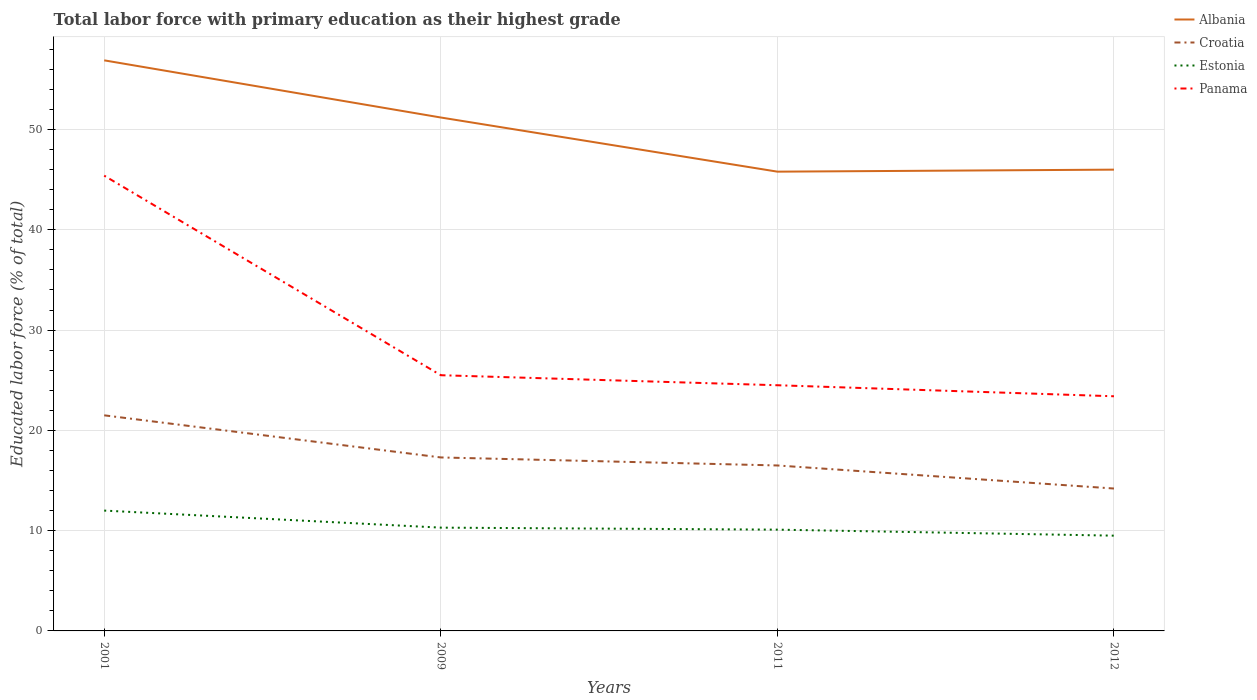How many different coloured lines are there?
Offer a very short reply. 4. Does the line corresponding to Estonia intersect with the line corresponding to Panama?
Offer a very short reply. No. Across all years, what is the maximum percentage of total labor force with primary education in Albania?
Ensure brevity in your answer.  45.8. What is the total percentage of total labor force with primary education in Croatia in the graph?
Offer a terse response. 7.3. What is the difference between the highest and the second highest percentage of total labor force with primary education in Croatia?
Keep it short and to the point. 7.3. What is the difference between the highest and the lowest percentage of total labor force with primary education in Estonia?
Your answer should be very brief. 1. Is the percentage of total labor force with primary education in Croatia strictly greater than the percentage of total labor force with primary education in Albania over the years?
Make the answer very short. Yes. How many years are there in the graph?
Your answer should be compact. 4. What is the difference between two consecutive major ticks on the Y-axis?
Provide a short and direct response. 10. Are the values on the major ticks of Y-axis written in scientific E-notation?
Offer a terse response. No. Does the graph contain grids?
Provide a short and direct response. Yes. Where does the legend appear in the graph?
Your answer should be compact. Top right. What is the title of the graph?
Your answer should be very brief. Total labor force with primary education as their highest grade. What is the label or title of the Y-axis?
Offer a very short reply. Educated labor force (% of total). What is the Educated labor force (% of total) in Albania in 2001?
Offer a terse response. 56.9. What is the Educated labor force (% of total) of Croatia in 2001?
Provide a succinct answer. 21.5. What is the Educated labor force (% of total) of Panama in 2001?
Give a very brief answer. 45.4. What is the Educated labor force (% of total) in Albania in 2009?
Your answer should be very brief. 51.2. What is the Educated labor force (% of total) of Croatia in 2009?
Provide a short and direct response. 17.3. What is the Educated labor force (% of total) of Estonia in 2009?
Provide a short and direct response. 10.3. What is the Educated labor force (% of total) of Albania in 2011?
Your response must be concise. 45.8. What is the Educated labor force (% of total) in Estonia in 2011?
Your response must be concise. 10.1. What is the Educated labor force (% of total) in Albania in 2012?
Offer a very short reply. 46. What is the Educated labor force (% of total) of Croatia in 2012?
Your response must be concise. 14.2. What is the Educated labor force (% of total) of Estonia in 2012?
Keep it short and to the point. 9.5. What is the Educated labor force (% of total) in Panama in 2012?
Keep it short and to the point. 23.4. Across all years, what is the maximum Educated labor force (% of total) in Albania?
Make the answer very short. 56.9. Across all years, what is the maximum Educated labor force (% of total) in Croatia?
Keep it short and to the point. 21.5. Across all years, what is the maximum Educated labor force (% of total) in Estonia?
Give a very brief answer. 12. Across all years, what is the maximum Educated labor force (% of total) in Panama?
Offer a very short reply. 45.4. Across all years, what is the minimum Educated labor force (% of total) of Albania?
Provide a succinct answer. 45.8. Across all years, what is the minimum Educated labor force (% of total) of Croatia?
Offer a very short reply. 14.2. Across all years, what is the minimum Educated labor force (% of total) in Panama?
Offer a terse response. 23.4. What is the total Educated labor force (% of total) in Albania in the graph?
Make the answer very short. 199.9. What is the total Educated labor force (% of total) of Croatia in the graph?
Keep it short and to the point. 69.5. What is the total Educated labor force (% of total) in Estonia in the graph?
Give a very brief answer. 41.9. What is the total Educated labor force (% of total) of Panama in the graph?
Provide a succinct answer. 118.8. What is the difference between the Educated labor force (% of total) of Albania in 2001 and that in 2011?
Ensure brevity in your answer.  11.1. What is the difference between the Educated labor force (% of total) of Croatia in 2001 and that in 2011?
Make the answer very short. 5. What is the difference between the Educated labor force (% of total) of Estonia in 2001 and that in 2011?
Offer a very short reply. 1.9. What is the difference between the Educated labor force (% of total) in Panama in 2001 and that in 2011?
Provide a succinct answer. 20.9. What is the difference between the Educated labor force (% of total) in Albania in 2001 and that in 2012?
Your response must be concise. 10.9. What is the difference between the Educated labor force (% of total) of Albania in 2009 and that in 2011?
Give a very brief answer. 5.4. What is the difference between the Educated labor force (% of total) in Croatia in 2009 and that in 2012?
Provide a short and direct response. 3.1. What is the difference between the Educated labor force (% of total) in Estonia in 2009 and that in 2012?
Your answer should be compact. 0.8. What is the difference between the Educated labor force (% of total) of Panama in 2009 and that in 2012?
Your answer should be very brief. 2.1. What is the difference between the Educated labor force (% of total) of Albania in 2011 and that in 2012?
Your answer should be compact. -0.2. What is the difference between the Educated labor force (% of total) of Croatia in 2011 and that in 2012?
Your response must be concise. 2.3. What is the difference between the Educated labor force (% of total) of Panama in 2011 and that in 2012?
Your answer should be compact. 1.1. What is the difference between the Educated labor force (% of total) of Albania in 2001 and the Educated labor force (% of total) of Croatia in 2009?
Offer a very short reply. 39.6. What is the difference between the Educated labor force (% of total) in Albania in 2001 and the Educated labor force (% of total) in Estonia in 2009?
Offer a very short reply. 46.6. What is the difference between the Educated labor force (% of total) of Albania in 2001 and the Educated labor force (% of total) of Panama in 2009?
Keep it short and to the point. 31.4. What is the difference between the Educated labor force (% of total) in Croatia in 2001 and the Educated labor force (% of total) in Panama in 2009?
Your answer should be very brief. -4. What is the difference between the Educated labor force (% of total) in Estonia in 2001 and the Educated labor force (% of total) in Panama in 2009?
Ensure brevity in your answer.  -13.5. What is the difference between the Educated labor force (% of total) in Albania in 2001 and the Educated labor force (% of total) in Croatia in 2011?
Offer a very short reply. 40.4. What is the difference between the Educated labor force (% of total) in Albania in 2001 and the Educated labor force (% of total) in Estonia in 2011?
Your answer should be very brief. 46.8. What is the difference between the Educated labor force (% of total) of Albania in 2001 and the Educated labor force (% of total) of Panama in 2011?
Your answer should be very brief. 32.4. What is the difference between the Educated labor force (% of total) in Croatia in 2001 and the Educated labor force (% of total) in Panama in 2011?
Provide a short and direct response. -3. What is the difference between the Educated labor force (% of total) in Albania in 2001 and the Educated labor force (% of total) in Croatia in 2012?
Provide a short and direct response. 42.7. What is the difference between the Educated labor force (% of total) of Albania in 2001 and the Educated labor force (% of total) of Estonia in 2012?
Your answer should be compact. 47.4. What is the difference between the Educated labor force (% of total) of Albania in 2001 and the Educated labor force (% of total) of Panama in 2012?
Ensure brevity in your answer.  33.5. What is the difference between the Educated labor force (% of total) in Croatia in 2001 and the Educated labor force (% of total) in Estonia in 2012?
Offer a terse response. 12. What is the difference between the Educated labor force (% of total) in Croatia in 2001 and the Educated labor force (% of total) in Panama in 2012?
Your response must be concise. -1.9. What is the difference between the Educated labor force (% of total) in Estonia in 2001 and the Educated labor force (% of total) in Panama in 2012?
Ensure brevity in your answer.  -11.4. What is the difference between the Educated labor force (% of total) of Albania in 2009 and the Educated labor force (% of total) of Croatia in 2011?
Offer a very short reply. 34.7. What is the difference between the Educated labor force (% of total) of Albania in 2009 and the Educated labor force (% of total) of Estonia in 2011?
Your response must be concise. 41.1. What is the difference between the Educated labor force (% of total) of Albania in 2009 and the Educated labor force (% of total) of Panama in 2011?
Provide a short and direct response. 26.7. What is the difference between the Educated labor force (% of total) of Croatia in 2009 and the Educated labor force (% of total) of Panama in 2011?
Keep it short and to the point. -7.2. What is the difference between the Educated labor force (% of total) of Estonia in 2009 and the Educated labor force (% of total) of Panama in 2011?
Your answer should be compact. -14.2. What is the difference between the Educated labor force (% of total) in Albania in 2009 and the Educated labor force (% of total) in Croatia in 2012?
Provide a short and direct response. 37. What is the difference between the Educated labor force (% of total) in Albania in 2009 and the Educated labor force (% of total) in Estonia in 2012?
Your response must be concise. 41.7. What is the difference between the Educated labor force (% of total) of Albania in 2009 and the Educated labor force (% of total) of Panama in 2012?
Keep it short and to the point. 27.8. What is the difference between the Educated labor force (% of total) in Croatia in 2009 and the Educated labor force (% of total) in Panama in 2012?
Your answer should be very brief. -6.1. What is the difference between the Educated labor force (% of total) in Albania in 2011 and the Educated labor force (% of total) in Croatia in 2012?
Your answer should be compact. 31.6. What is the difference between the Educated labor force (% of total) of Albania in 2011 and the Educated labor force (% of total) of Estonia in 2012?
Provide a short and direct response. 36.3. What is the difference between the Educated labor force (% of total) of Albania in 2011 and the Educated labor force (% of total) of Panama in 2012?
Make the answer very short. 22.4. What is the difference between the Educated labor force (% of total) of Estonia in 2011 and the Educated labor force (% of total) of Panama in 2012?
Ensure brevity in your answer.  -13.3. What is the average Educated labor force (% of total) in Albania per year?
Provide a succinct answer. 49.98. What is the average Educated labor force (% of total) of Croatia per year?
Offer a very short reply. 17.38. What is the average Educated labor force (% of total) of Estonia per year?
Your response must be concise. 10.47. What is the average Educated labor force (% of total) of Panama per year?
Ensure brevity in your answer.  29.7. In the year 2001, what is the difference between the Educated labor force (% of total) in Albania and Educated labor force (% of total) in Croatia?
Ensure brevity in your answer.  35.4. In the year 2001, what is the difference between the Educated labor force (% of total) of Albania and Educated labor force (% of total) of Estonia?
Your answer should be compact. 44.9. In the year 2001, what is the difference between the Educated labor force (% of total) in Albania and Educated labor force (% of total) in Panama?
Offer a very short reply. 11.5. In the year 2001, what is the difference between the Educated labor force (% of total) in Croatia and Educated labor force (% of total) in Estonia?
Offer a terse response. 9.5. In the year 2001, what is the difference between the Educated labor force (% of total) in Croatia and Educated labor force (% of total) in Panama?
Your response must be concise. -23.9. In the year 2001, what is the difference between the Educated labor force (% of total) in Estonia and Educated labor force (% of total) in Panama?
Your answer should be compact. -33.4. In the year 2009, what is the difference between the Educated labor force (% of total) of Albania and Educated labor force (% of total) of Croatia?
Ensure brevity in your answer.  33.9. In the year 2009, what is the difference between the Educated labor force (% of total) in Albania and Educated labor force (% of total) in Estonia?
Offer a very short reply. 40.9. In the year 2009, what is the difference between the Educated labor force (% of total) in Albania and Educated labor force (% of total) in Panama?
Provide a short and direct response. 25.7. In the year 2009, what is the difference between the Educated labor force (% of total) of Croatia and Educated labor force (% of total) of Estonia?
Your answer should be very brief. 7. In the year 2009, what is the difference between the Educated labor force (% of total) of Croatia and Educated labor force (% of total) of Panama?
Provide a short and direct response. -8.2. In the year 2009, what is the difference between the Educated labor force (% of total) in Estonia and Educated labor force (% of total) in Panama?
Provide a short and direct response. -15.2. In the year 2011, what is the difference between the Educated labor force (% of total) in Albania and Educated labor force (% of total) in Croatia?
Your answer should be very brief. 29.3. In the year 2011, what is the difference between the Educated labor force (% of total) in Albania and Educated labor force (% of total) in Estonia?
Ensure brevity in your answer.  35.7. In the year 2011, what is the difference between the Educated labor force (% of total) of Albania and Educated labor force (% of total) of Panama?
Your answer should be very brief. 21.3. In the year 2011, what is the difference between the Educated labor force (% of total) of Croatia and Educated labor force (% of total) of Estonia?
Ensure brevity in your answer.  6.4. In the year 2011, what is the difference between the Educated labor force (% of total) in Croatia and Educated labor force (% of total) in Panama?
Ensure brevity in your answer.  -8. In the year 2011, what is the difference between the Educated labor force (% of total) in Estonia and Educated labor force (% of total) in Panama?
Provide a short and direct response. -14.4. In the year 2012, what is the difference between the Educated labor force (% of total) in Albania and Educated labor force (% of total) in Croatia?
Your answer should be compact. 31.8. In the year 2012, what is the difference between the Educated labor force (% of total) of Albania and Educated labor force (% of total) of Estonia?
Ensure brevity in your answer.  36.5. In the year 2012, what is the difference between the Educated labor force (% of total) in Albania and Educated labor force (% of total) in Panama?
Provide a succinct answer. 22.6. In the year 2012, what is the difference between the Educated labor force (% of total) of Croatia and Educated labor force (% of total) of Panama?
Offer a terse response. -9.2. In the year 2012, what is the difference between the Educated labor force (% of total) in Estonia and Educated labor force (% of total) in Panama?
Give a very brief answer. -13.9. What is the ratio of the Educated labor force (% of total) in Albania in 2001 to that in 2009?
Your response must be concise. 1.11. What is the ratio of the Educated labor force (% of total) of Croatia in 2001 to that in 2009?
Give a very brief answer. 1.24. What is the ratio of the Educated labor force (% of total) in Estonia in 2001 to that in 2009?
Your answer should be compact. 1.17. What is the ratio of the Educated labor force (% of total) of Panama in 2001 to that in 2009?
Give a very brief answer. 1.78. What is the ratio of the Educated labor force (% of total) of Albania in 2001 to that in 2011?
Your answer should be compact. 1.24. What is the ratio of the Educated labor force (% of total) of Croatia in 2001 to that in 2011?
Give a very brief answer. 1.3. What is the ratio of the Educated labor force (% of total) in Estonia in 2001 to that in 2011?
Your response must be concise. 1.19. What is the ratio of the Educated labor force (% of total) of Panama in 2001 to that in 2011?
Offer a terse response. 1.85. What is the ratio of the Educated labor force (% of total) of Albania in 2001 to that in 2012?
Make the answer very short. 1.24. What is the ratio of the Educated labor force (% of total) in Croatia in 2001 to that in 2012?
Provide a short and direct response. 1.51. What is the ratio of the Educated labor force (% of total) in Estonia in 2001 to that in 2012?
Provide a short and direct response. 1.26. What is the ratio of the Educated labor force (% of total) in Panama in 2001 to that in 2012?
Your answer should be compact. 1.94. What is the ratio of the Educated labor force (% of total) of Albania in 2009 to that in 2011?
Your answer should be very brief. 1.12. What is the ratio of the Educated labor force (% of total) in Croatia in 2009 to that in 2011?
Your answer should be very brief. 1.05. What is the ratio of the Educated labor force (% of total) in Estonia in 2009 to that in 2011?
Your answer should be compact. 1.02. What is the ratio of the Educated labor force (% of total) of Panama in 2009 to that in 2011?
Ensure brevity in your answer.  1.04. What is the ratio of the Educated labor force (% of total) in Albania in 2009 to that in 2012?
Keep it short and to the point. 1.11. What is the ratio of the Educated labor force (% of total) in Croatia in 2009 to that in 2012?
Give a very brief answer. 1.22. What is the ratio of the Educated labor force (% of total) of Estonia in 2009 to that in 2012?
Your response must be concise. 1.08. What is the ratio of the Educated labor force (% of total) of Panama in 2009 to that in 2012?
Provide a succinct answer. 1.09. What is the ratio of the Educated labor force (% of total) of Croatia in 2011 to that in 2012?
Offer a terse response. 1.16. What is the ratio of the Educated labor force (% of total) in Estonia in 2011 to that in 2012?
Make the answer very short. 1.06. What is the ratio of the Educated labor force (% of total) in Panama in 2011 to that in 2012?
Provide a succinct answer. 1.05. What is the difference between the highest and the second highest Educated labor force (% of total) in Albania?
Your answer should be very brief. 5.7. What is the difference between the highest and the second highest Educated labor force (% of total) in Croatia?
Provide a short and direct response. 4.2. What is the difference between the highest and the second highest Educated labor force (% of total) in Panama?
Give a very brief answer. 19.9. What is the difference between the highest and the lowest Educated labor force (% of total) in Estonia?
Provide a short and direct response. 2.5. What is the difference between the highest and the lowest Educated labor force (% of total) of Panama?
Provide a succinct answer. 22. 